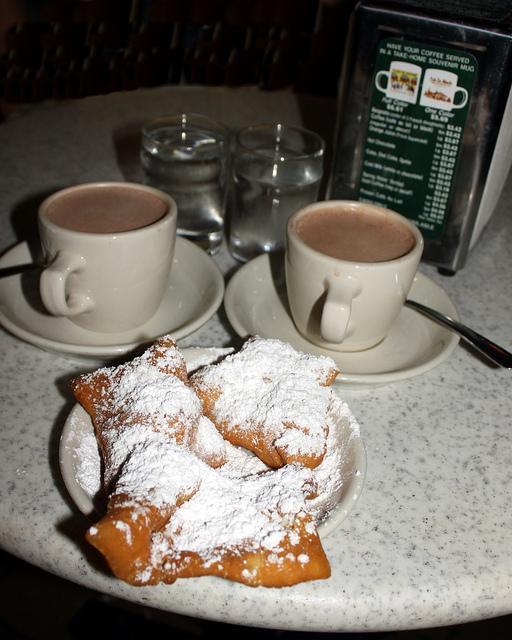How many cups are there?
Give a very brief answer. 4. 